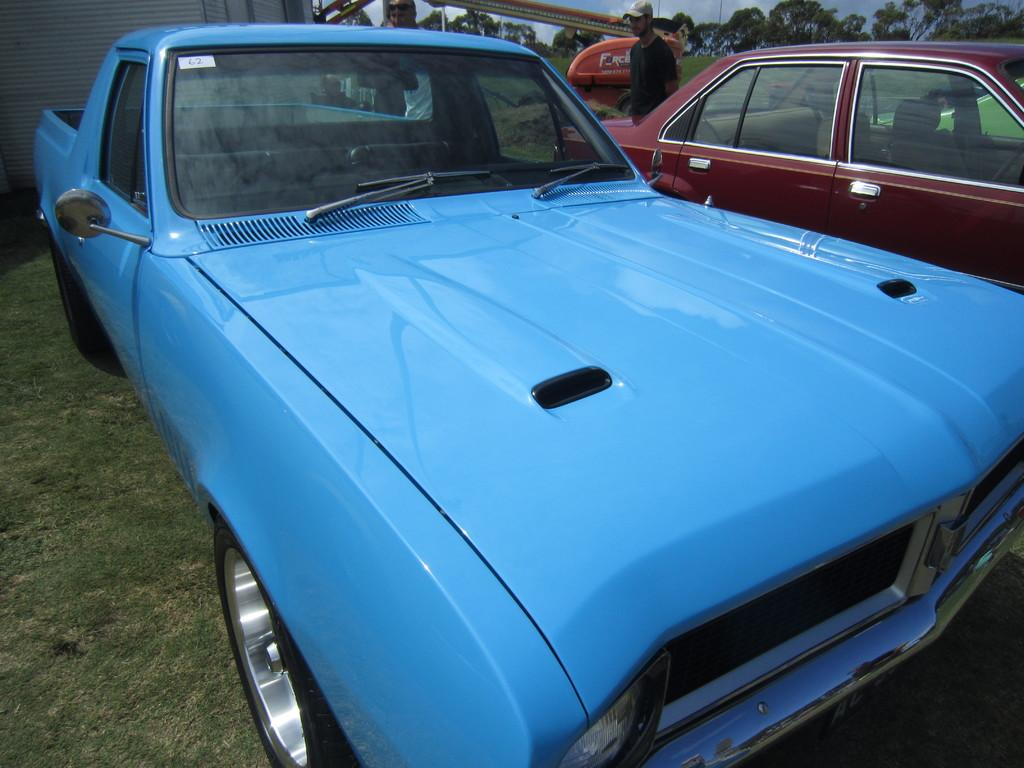What can be seen in the foreground of the picture? There are two cars in the foreground of the picture. What is located in the center of the picture? There are people in the center of the picture. What is visible in the background of the picture? There are trees and sky visible in the background of the picture. What structure is on the left side of the picture? There is a building on the left side of the picture. Is the queen sitting on a swing in the picture? There is no queen or swing present in the image. What is the temperature like in the picture? The temperature or heat level cannot be determined from the image, as it only provides visual information. 